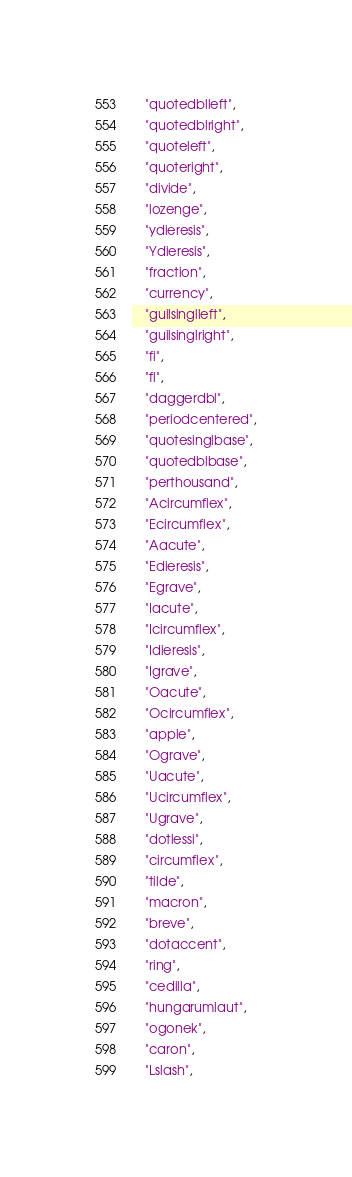Convert code to text. <code><loc_0><loc_0><loc_500><loc_500><_Rust_>    "quotedblleft",
    "quotedblright",
    "quoteleft",
    "quoteright",
    "divide",
    "lozenge",
    "ydieresis",
    "Ydieresis",
    "fraction",
    "currency",
    "guilsinglleft",
    "guilsinglright",
    "fi",
    "fl",
    "daggerdbl",
    "periodcentered",
    "quotesinglbase",
    "quotedblbase",
    "perthousand",
    "Acircumflex",
    "Ecircumflex",
    "Aacute",
    "Edieresis",
    "Egrave",
    "Iacute",
    "Icircumflex",
    "Idieresis",
    "Igrave",
    "Oacute",
    "Ocircumflex",
    "apple",
    "Ograve",
    "Uacute",
    "Ucircumflex",
    "Ugrave",
    "dotlessi",
    "circumflex",
    "tilde",
    "macron",
    "breve",
    "dotaccent",
    "ring",
    "cedilla",
    "hungarumlaut",
    "ogonek",
    "caron",
    "Lslash",</code> 